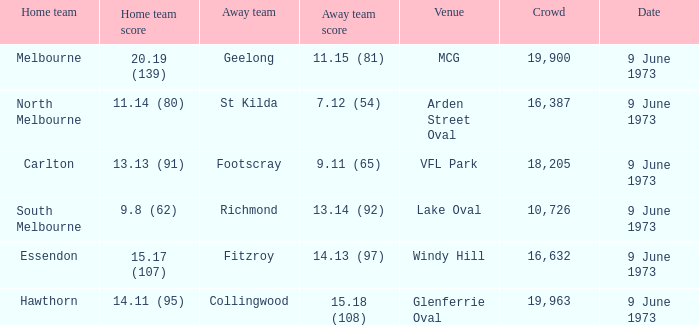Could you parse the entire table as a dict? {'header': ['Home team', 'Home team score', 'Away team', 'Away team score', 'Venue', 'Crowd', 'Date'], 'rows': [['Melbourne', '20.19 (139)', 'Geelong', '11.15 (81)', 'MCG', '19,900', '9 June 1973'], ['North Melbourne', '11.14 (80)', 'St Kilda', '7.12 (54)', 'Arden Street Oval', '16,387', '9 June 1973'], ['Carlton', '13.13 (91)', 'Footscray', '9.11 (65)', 'VFL Park', '18,205', '9 June 1973'], ['South Melbourne', '9.8 (62)', 'Richmond', '13.14 (92)', 'Lake Oval', '10,726', '9 June 1973'], ['Essendon', '15.17 (107)', 'Fitzroy', '14.13 (97)', 'Windy Hill', '16,632', '9 June 1973'], ['Hawthorn', '14.11 (95)', 'Collingwood', '15.18 (108)', 'Glenferrie Oval', '19,963', '9 June 1973']]} Where did Fitzroy play as the away team? Windy Hill. 